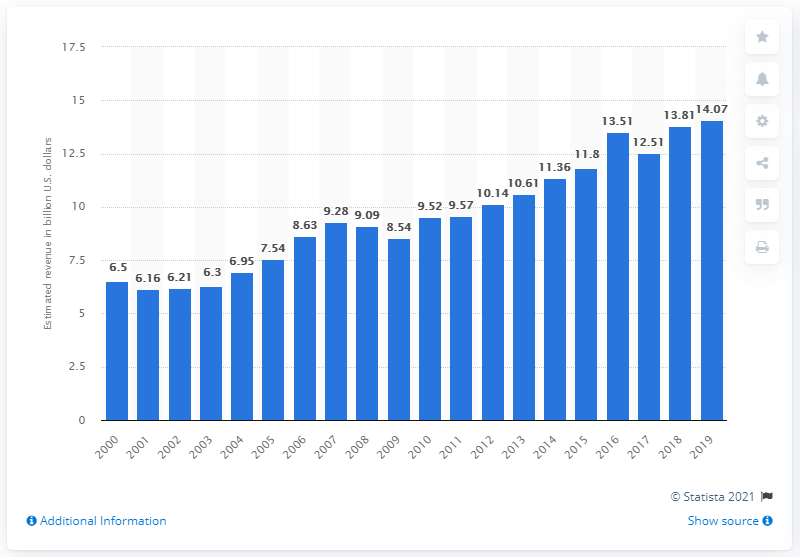List a handful of essential elements in this visual. In 2019, the total revenue of U.S public relations agencies was 14.07 billion dollars. 